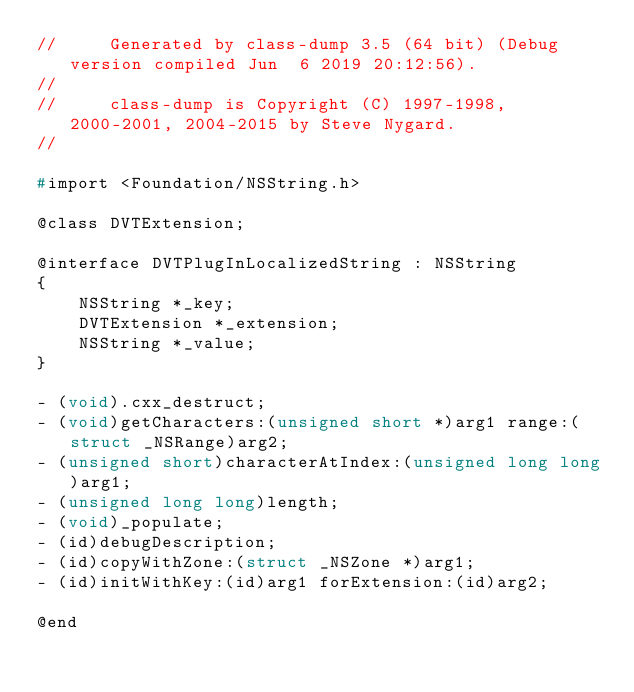Convert code to text. <code><loc_0><loc_0><loc_500><loc_500><_C_>//     Generated by class-dump 3.5 (64 bit) (Debug version compiled Jun  6 2019 20:12:56).
//
//     class-dump is Copyright (C) 1997-1998, 2000-2001, 2004-2015 by Steve Nygard.
//

#import <Foundation/NSString.h>

@class DVTExtension;

@interface DVTPlugInLocalizedString : NSString
{
    NSString *_key;
    DVTExtension *_extension;
    NSString *_value;
}

- (void).cxx_destruct;
- (void)getCharacters:(unsigned short *)arg1 range:(struct _NSRange)arg2;
- (unsigned short)characterAtIndex:(unsigned long long)arg1;
- (unsigned long long)length;
- (void)_populate;
- (id)debugDescription;
- (id)copyWithZone:(struct _NSZone *)arg1;
- (id)initWithKey:(id)arg1 forExtension:(id)arg2;

@end

</code> 